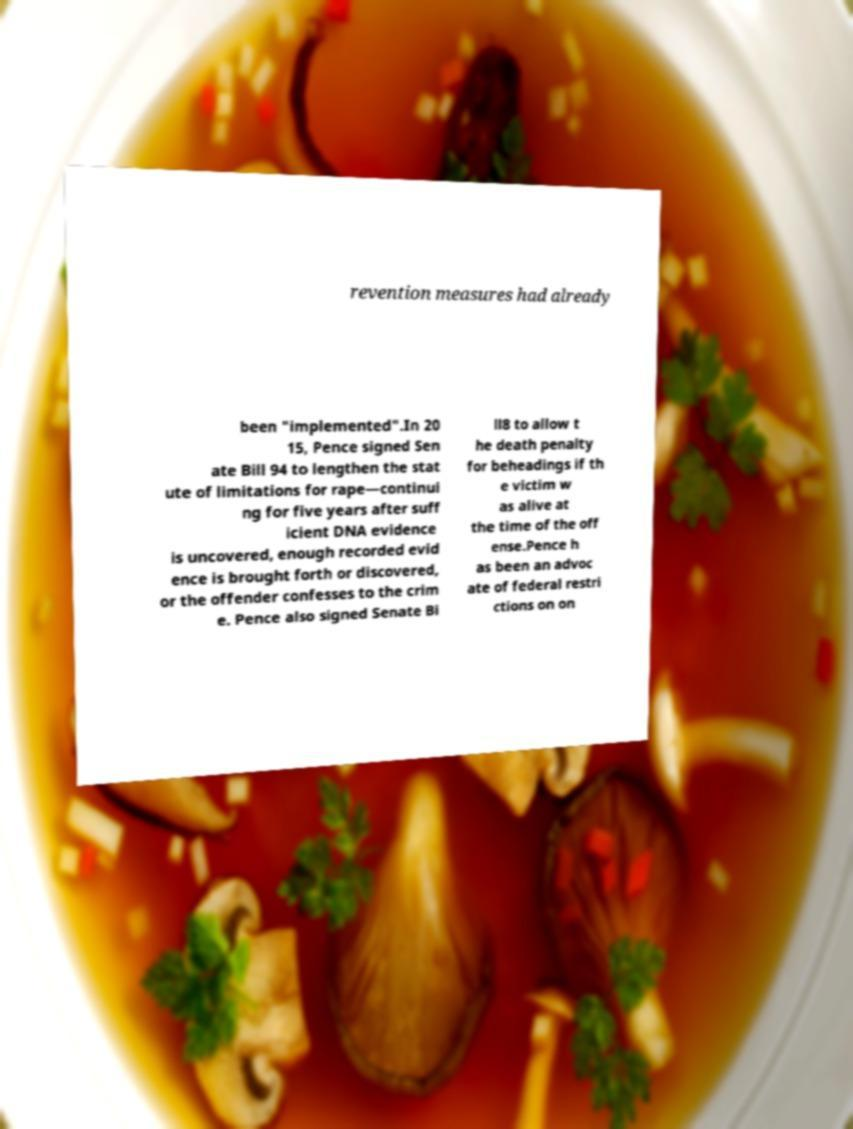Could you extract and type out the text from this image? revention measures had already been "implemented".In 20 15, Pence signed Sen ate Bill 94 to lengthen the stat ute of limitations for rape—continui ng for five years after suff icient DNA evidence is uncovered, enough recorded evid ence is brought forth or discovered, or the offender confesses to the crim e. Pence also signed Senate Bi ll8 to allow t he death penalty for beheadings if th e victim w as alive at the time of the off ense.Pence h as been an advoc ate of federal restri ctions on on 